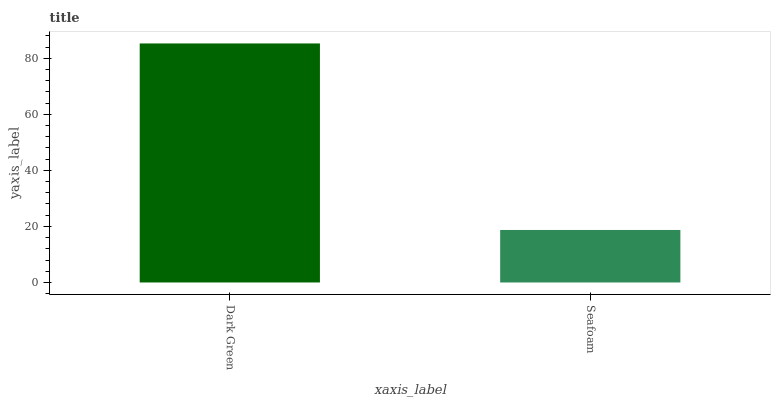Is Seafoam the minimum?
Answer yes or no. Yes. Is Dark Green the maximum?
Answer yes or no. Yes. Is Seafoam the maximum?
Answer yes or no. No. Is Dark Green greater than Seafoam?
Answer yes or no. Yes. Is Seafoam less than Dark Green?
Answer yes or no. Yes. Is Seafoam greater than Dark Green?
Answer yes or no. No. Is Dark Green less than Seafoam?
Answer yes or no. No. Is Dark Green the high median?
Answer yes or no. Yes. Is Seafoam the low median?
Answer yes or no. Yes. Is Seafoam the high median?
Answer yes or no. No. Is Dark Green the low median?
Answer yes or no. No. 